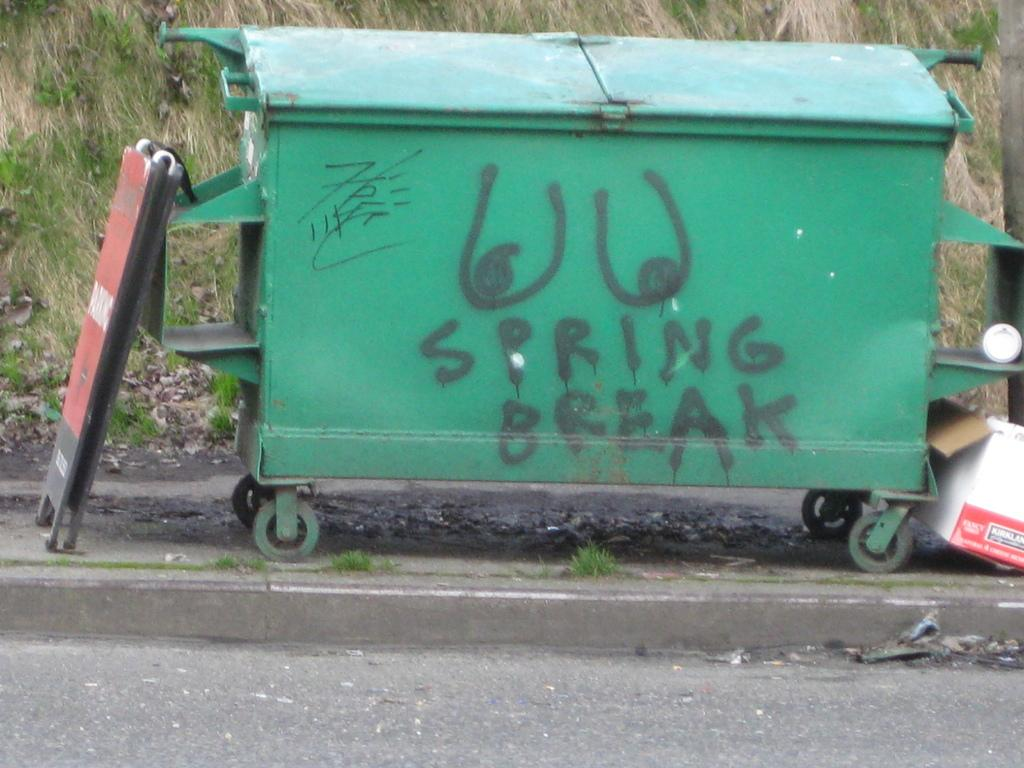<image>
Write a terse but informative summary of the picture. A green dumpster has the words spring break written on it in black paint. 